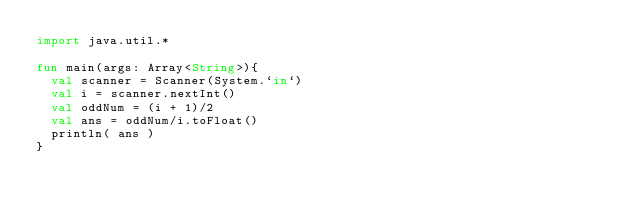Convert code to text. <code><loc_0><loc_0><loc_500><loc_500><_Kotlin_>import java.util.*

fun main(args: Array<String>){
  val scanner = Scanner(System.`in`)
  val i = scanner.nextInt()
  val oddNum = (i + 1)/2
  val ans = oddNum/i.toFloat()
  println( ans )
}
</code> 